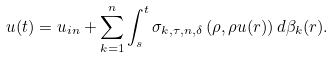Convert formula to latex. <formula><loc_0><loc_0><loc_500><loc_500>u ( t ) = u _ { i n } + \sum _ { k = 1 } ^ { n } \int _ { s } ^ { t } \sigma _ { k , \tau , n , \delta } \left ( \rho , \rho u ( r ) \right ) d \beta _ { k } ( r ) .</formula> 